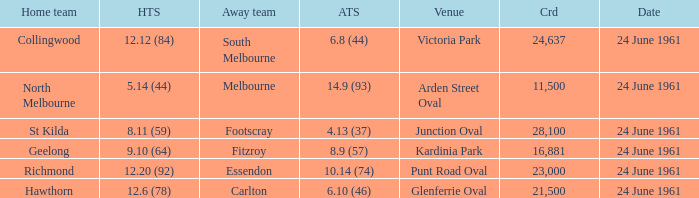Which home side scored 1 Hawthorn. 